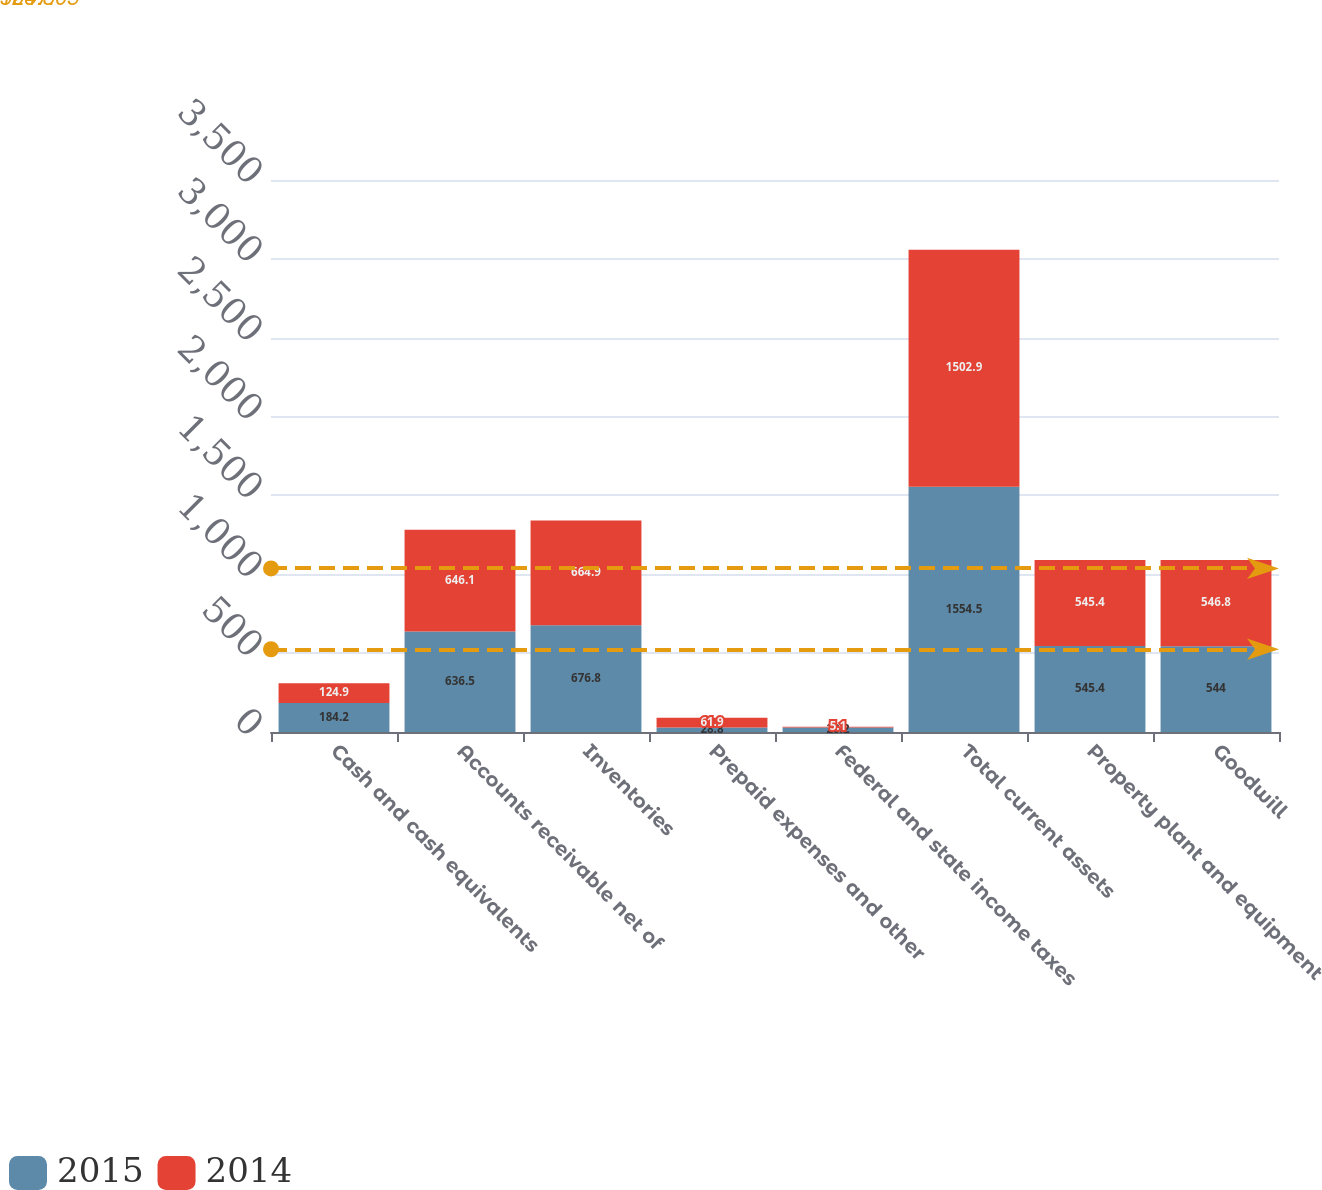Convert chart. <chart><loc_0><loc_0><loc_500><loc_500><stacked_bar_chart><ecel><fcel>Cash and cash equivalents<fcel>Accounts receivable net of<fcel>Inventories<fcel>Prepaid expenses and other<fcel>Federal and state income taxes<fcel>Total current assets<fcel>Property plant and equipment<fcel>Goodwill<nl><fcel>2015<fcel>184.2<fcel>636.5<fcel>676.8<fcel>28.8<fcel>28.2<fcel>1554.5<fcel>545.4<fcel>544<nl><fcel>2014<fcel>124.9<fcel>646.1<fcel>664.9<fcel>61.9<fcel>5.1<fcel>1502.9<fcel>545.4<fcel>546.8<nl></chart> 